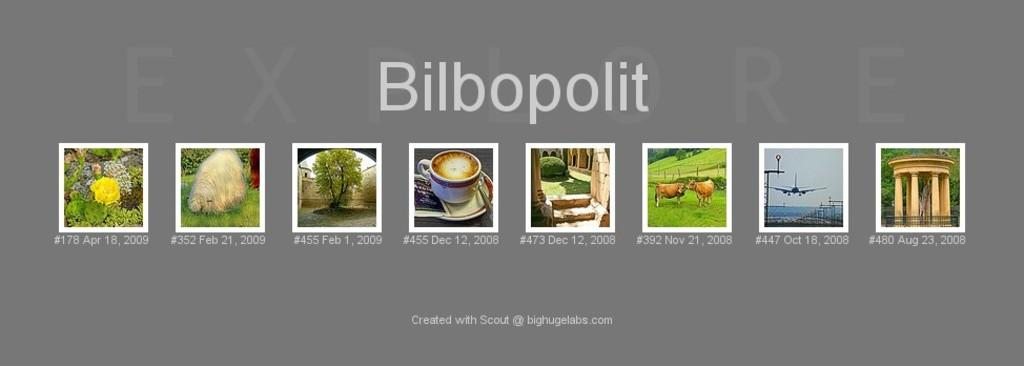What type of visual display is shown in the image? The image appears to be a poster. What natural elements are depicted on the poster? The poster contains pictures of trees and flowers. What man-made objects are shown on the poster? The poster contains a picture of a cup with a saucer, an airplane, and an architecture. Where are the scissors placed on the poster? There are no scissors present on the poster. What type of bulb is shown illuminating the architecture on the poster? There is no bulb depicted on the poster, as it only features pictures of trees, flowers, a cup with a saucer, an airplane, and an architecture. 